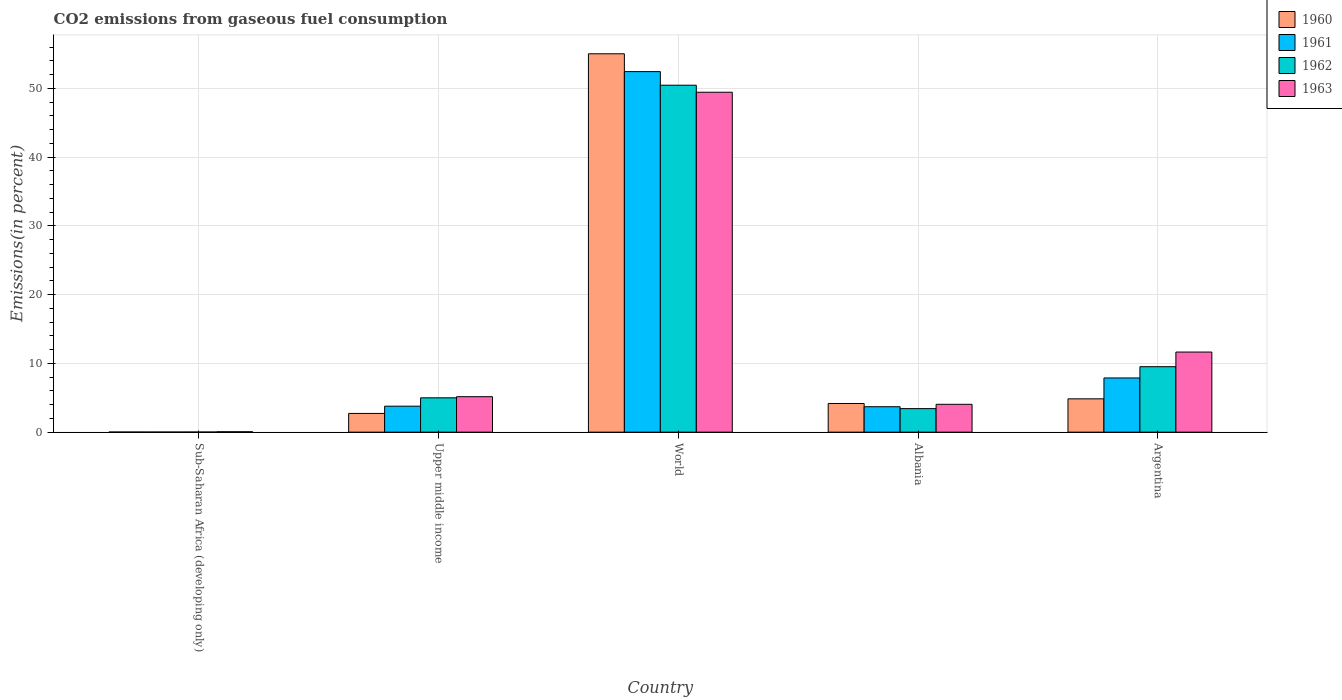How many groups of bars are there?
Ensure brevity in your answer.  5. What is the label of the 2nd group of bars from the left?
Provide a short and direct response. Upper middle income. In how many cases, is the number of bars for a given country not equal to the number of legend labels?
Make the answer very short. 0. What is the total CO2 emitted in 1960 in Argentina?
Your response must be concise. 4.85. Across all countries, what is the maximum total CO2 emitted in 1962?
Make the answer very short. 50.46. Across all countries, what is the minimum total CO2 emitted in 1962?
Give a very brief answer. 0.01. In which country was the total CO2 emitted in 1960 maximum?
Your answer should be compact. World. In which country was the total CO2 emitted in 1963 minimum?
Offer a very short reply. Sub-Saharan Africa (developing only). What is the total total CO2 emitted in 1963 in the graph?
Provide a succinct answer. 70.34. What is the difference between the total CO2 emitted in 1961 in Albania and that in Sub-Saharan Africa (developing only)?
Provide a succinct answer. 3.69. What is the difference between the total CO2 emitted in 1962 in World and the total CO2 emitted in 1960 in Sub-Saharan Africa (developing only)?
Provide a short and direct response. 50.44. What is the average total CO2 emitted in 1960 per country?
Make the answer very short. 13.35. What is the difference between the total CO2 emitted of/in 1960 and total CO2 emitted of/in 1962 in Argentina?
Your response must be concise. -4.67. In how many countries, is the total CO2 emitted in 1960 greater than 26 %?
Offer a terse response. 1. What is the ratio of the total CO2 emitted in 1962 in Sub-Saharan Africa (developing only) to that in Upper middle income?
Your answer should be very brief. 0. What is the difference between the highest and the second highest total CO2 emitted in 1963?
Offer a very short reply. 37.78. What is the difference between the highest and the lowest total CO2 emitted in 1962?
Offer a very short reply. 50.44. Is it the case that in every country, the sum of the total CO2 emitted in 1963 and total CO2 emitted in 1960 is greater than the sum of total CO2 emitted in 1961 and total CO2 emitted in 1962?
Your answer should be very brief. No. What does the 4th bar from the left in World represents?
Make the answer very short. 1963. How many bars are there?
Provide a succinct answer. 20. What is the difference between two consecutive major ticks on the Y-axis?
Provide a succinct answer. 10. Does the graph contain any zero values?
Provide a short and direct response. No. Where does the legend appear in the graph?
Your answer should be very brief. Top right. How many legend labels are there?
Provide a short and direct response. 4. What is the title of the graph?
Offer a terse response. CO2 emissions from gaseous fuel consumption. What is the label or title of the Y-axis?
Keep it short and to the point. Emissions(in percent). What is the Emissions(in percent) in 1960 in Sub-Saharan Africa (developing only)?
Make the answer very short. 0.01. What is the Emissions(in percent) of 1961 in Sub-Saharan Africa (developing only)?
Offer a very short reply. 0.01. What is the Emissions(in percent) of 1962 in Sub-Saharan Africa (developing only)?
Ensure brevity in your answer.  0.01. What is the Emissions(in percent) of 1963 in Sub-Saharan Africa (developing only)?
Keep it short and to the point. 0.06. What is the Emissions(in percent) of 1960 in Upper middle income?
Provide a succinct answer. 2.72. What is the Emissions(in percent) of 1961 in Upper middle income?
Give a very brief answer. 3.78. What is the Emissions(in percent) in 1962 in Upper middle income?
Provide a succinct answer. 4.99. What is the Emissions(in percent) in 1963 in Upper middle income?
Ensure brevity in your answer.  5.15. What is the Emissions(in percent) of 1960 in World?
Make the answer very short. 55.02. What is the Emissions(in percent) of 1961 in World?
Provide a short and direct response. 52.43. What is the Emissions(in percent) in 1962 in World?
Make the answer very short. 50.46. What is the Emissions(in percent) in 1963 in World?
Provide a short and direct response. 49.43. What is the Emissions(in percent) of 1960 in Albania?
Offer a terse response. 4.17. What is the Emissions(in percent) of 1961 in Albania?
Offer a terse response. 3.7. What is the Emissions(in percent) of 1962 in Albania?
Your response must be concise. 3.42. What is the Emissions(in percent) of 1963 in Albania?
Offer a very short reply. 4.05. What is the Emissions(in percent) of 1960 in Argentina?
Provide a succinct answer. 4.85. What is the Emissions(in percent) of 1961 in Argentina?
Give a very brief answer. 7.88. What is the Emissions(in percent) in 1962 in Argentina?
Your response must be concise. 9.52. What is the Emissions(in percent) of 1963 in Argentina?
Your answer should be very brief. 11.65. Across all countries, what is the maximum Emissions(in percent) of 1960?
Provide a short and direct response. 55.02. Across all countries, what is the maximum Emissions(in percent) of 1961?
Your answer should be very brief. 52.43. Across all countries, what is the maximum Emissions(in percent) of 1962?
Your response must be concise. 50.46. Across all countries, what is the maximum Emissions(in percent) in 1963?
Your answer should be compact. 49.43. Across all countries, what is the minimum Emissions(in percent) of 1960?
Give a very brief answer. 0.01. Across all countries, what is the minimum Emissions(in percent) of 1961?
Ensure brevity in your answer.  0.01. Across all countries, what is the minimum Emissions(in percent) of 1962?
Make the answer very short. 0.01. Across all countries, what is the minimum Emissions(in percent) in 1963?
Offer a very short reply. 0.06. What is the total Emissions(in percent) of 1960 in the graph?
Your answer should be compact. 66.77. What is the total Emissions(in percent) in 1961 in the graph?
Provide a short and direct response. 67.8. What is the total Emissions(in percent) in 1962 in the graph?
Your response must be concise. 68.41. What is the total Emissions(in percent) in 1963 in the graph?
Ensure brevity in your answer.  70.34. What is the difference between the Emissions(in percent) in 1960 in Sub-Saharan Africa (developing only) and that in Upper middle income?
Keep it short and to the point. -2.71. What is the difference between the Emissions(in percent) of 1961 in Sub-Saharan Africa (developing only) and that in Upper middle income?
Offer a very short reply. -3.77. What is the difference between the Emissions(in percent) of 1962 in Sub-Saharan Africa (developing only) and that in Upper middle income?
Keep it short and to the point. -4.98. What is the difference between the Emissions(in percent) of 1963 in Sub-Saharan Africa (developing only) and that in Upper middle income?
Your answer should be very brief. -5.1. What is the difference between the Emissions(in percent) in 1960 in Sub-Saharan Africa (developing only) and that in World?
Ensure brevity in your answer.  -55.01. What is the difference between the Emissions(in percent) in 1961 in Sub-Saharan Africa (developing only) and that in World?
Offer a very short reply. -52.42. What is the difference between the Emissions(in percent) in 1962 in Sub-Saharan Africa (developing only) and that in World?
Offer a terse response. -50.44. What is the difference between the Emissions(in percent) in 1963 in Sub-Saharan Africa (developing only) and that in World?
Ensure brevity in your answer.  -49.38. What is the difference between the Emissions(in percent) in 1960 in Sub-Saharan Africa (developing only) and that in Albania?
Your answer should be very brief. -4.15. What is the difference between the Emissions(in percent) of 1961 in Sub-Saharan Africa (developing only) and that in Albania?
Make the answer very short. -3.69. What is the difference between the Emissions(in percent) of 1962 in Sub-Saharan Africa (developing only) and that in Albania?
Your answer should be very brief. -3.41. What is the difference between the Emissions(in percent) of 1963 in Sub-Saharan Africa (developing only) and that in Albania?
Offer a very short reply. -3.99. What is the difference between the Emissions(in percent) of 1960 in Sub-Saharan Africa (developing only) and that in Argentina?
Your answer should be very brief. -4.83. What is the difference between the Emissions(in percent) of 1961 in Sub-Saharan Africa (developing only) and that in Argentina?
Your answer should be very brief. -7.87. What is the difference between the Emissions(in percent) in 1962 in Sub-Saharan Africa (developing only) and that in Argentina?
Give a very brief answer. -9.51. What is the difference between the Emissions(in percent) in 1963 in Sub-Saharan Africa (developing only) and that in Argentina?
Provide a succinct answer. -11.59. What is the difference between the Emissions(in percent) in 1960 in Upper middle income and that in World?
Provide a succinct answer. -52.3. What is the difference between the Emissions(in percent) in 1961 in Upper middle income and that in World?
Provide a succinct answer. -48.66. What is the difference between the Emissions(in percent) in 1962 in Upper middle income and that in World?
Your answer should be very brief. -45.46. What is the difference between the Emissions(in percent) in 1963 in Upper middle income and that in World?
Your answer should be very brief. -44.28. What is the difference between the Emissions(in percent) in 1960 in Upper middle income and that in Albania?
Your answer should be compact. -1.44. What is the difference between the Emissions(in percent) in 1961 in Upper middle income and that in Albania?
Give a very brief answer. 0.08. What is the difference between the Emissions(in percent) of 1962 in Upper middle income and that in Albania?
Offer a terse response. 1.57. What is the difference between the Emissions(in percent) of 1963 in Upper middle income and that in Albania?
Keep it short and to the point. 1.11. What is the difference between the Emissions(in percent) in 1960 in Upper middle income and that in Argentina?
Give a very brief answer. -2.12. What is the difference between the Emissions(in percent) in 1961 in Upper middle income and that in Argentina?
Your response must be concise. -4.1. What is the difference between the Emissions(in percent) of 1962 in Upper middle income and that in Argentina?
Offer a terse response. -4.53. What is the difference between the Emissions(in percent) of 1963 in Upper middle income and that in Argentina?
Your response must be concise. -6.49. What is the difference between the Emissions(in percent) of 1960 in World and that in Albania?
Your answer should be very brief. 50.86. What is the difference between the Emissions(in percent) in 1961 in World and that in Albania?
Offer a very short reply. 48.74. What is the difference between the Emissions(in percent) of 1962 in World and that in Albania?
Give a very brief answer. 47.03. What is the difference between the Emissions(in percent) of 1963 in World and that in Albania?
Offer a terse response. 45.38. What is the difference between the Emissions(in percent) of 1960 in World and that in Argentina?
Provide a succinct answer. 50.18. What is the difference between the Emissions(in percent) in 1961 in World and that in Argentina?
Provide a short and direct response. 44.55. What is the difference between the Emissions(in percent) of 1962 in World and that in Argentina?
Make the answer very short. 40.94. What is the difference between the Emissions(in percent) in 1963 in World and that in Argentina?
Offer a terse response. 37.78. What is the difference between the Emissions(in percent) of 1960 in Albania and that in Argentina?
Provide a short and direct response. -0.68. What is the difference between the Emissions(in percent) of 1961 in Albania and that in Argentina?
Provide a short and direct response. -4.18. What is the difference between the Emissions(in percent) of 1962 in Albania and that in Argentina?
Ensure brevity in your answer.  -6.1. What is the difference between the Emissions(in percent) in 1963 in Albania and that in Argentina?
Provide a succinct answer. -7.6. What is the difference between the Emissions(in percent) of 1960 in Sub-Saharan Africa (developing only) and the Emissions(in percent) of 1961 in Upper middle income?
Your response must be concise. -3.77. What is the difference between the Emissions(in percent) of 1960 in Sub-Saharan Africa (developing only) and the Emissions(in percent) of 1962 in Upper middle income?
Offer a very short reply. -4.98. What is the difference between the Emissions(in percent) of 1960 in Sub-Saharan Africa (developing only) and the Emissions(in percent) of 1963 in Upper middle income?
Your answer should be very brief. -5.14. What is the difference between the Emissions(in percent) of 1961 in Sub-Saharan Africa (developing only) and the Emissions(in percent) of 1962 in Upper middle income?
Offer a terse response. -4.98. What is the difference between the Emissions(in percent) in 1961 in Sub-Saharan Africa (developing only) and the Emissions(in percent) in 1963 in Upper middle income?
Offer a very short reply. -5.14. What is the difference between the Emissions(in percent) of 1962 in Sub-Saharan Africa (developing only) and the Emissions(in percent) of 1963 in Upper middle income?
Provide a short and direct response. -5.14. What is the difference between the Emissions(in percent) in 1960 in Sub-Saharan Africa (developing only) and the Emissions(in percent) in 1961 in World?
Give a very brief answer. -52.42. What is the difference between the Emissions(in percent) in 1960 in Sub-Saharan Africa (developing only) and the Emissions(in percent) in 1962 in World?
Your answer should be compact. -50.44. What is the difference between the Emissions(in percent) in 1960 in Sub-Saharan Africa (developing only) and the Emissions(in percent) in 1963 in World?
Give a very brief answer. -49.42. What is the difference between the Emissions(in percent) in 1961 in Sub-Saharan Africa (developing only) and the Emissions(in percent) in 1962 in World?
Your response must be concise. -50.44. What is the difference between the Emissions(in percent) in 1961 in Sub-Saharan Africa (developing only) and the Emissions(in percent) in 1963 in World?
Provide a succinct answer. -49.42. What is the difference between the Emissions(in percent) in 1962 in Sub-Saharan Africa (developing only) and the Emissions(in percent) in 1963 in World?
Your response must be concise. -49.42. What is the difference between the Emissions(in percent) of 1960 in Sub-Saharan Africa (developing only) and the Emissions(in percent) of 1961 in Albania?
Make the answer very short. -3.69. What is the difference between the Emissions(in percent) in 1960 in Sub-Saharan Africa (developing only) and the Emissions(in percent) in 1962 in Albania?
Your answer should be very brief. -3.41. What is the difference between the Emissions(in percent) in 1960 in Sub-Saharan Africa (developing only) and the Emissions(in percent) in 1963 in Albania?
Provide a short and direct response. -4.04. What is the difference between the Emissions(in percent) in 1961 in Sub-Saharan Africa (developing only) and the Emissions(in percent) in 1962 in Albania?
Your answer should be compact. -3.41. What is the difference between the Emissions(in percent) in 1961 in Sub-Saharan Africa (developing only) and the Emissions(in percent) in 1963 in Albania?
Offer a very short reply. -4.04. What is the difference between the Emissions(in percent) of 1962 in Sub-Saharan Africa (developing only) and the Emissions(in percent) of 1963 in Albania?
Offer a terse response. -4.03. What is the difference between the Emissions(in percent) in 1960 in Sub-Saharan Africa (developing only) and the Emissions(in percent) in 1961 in Argentina?
Offer a terse response. -7.87. What is the difference between the Emissions(in percent) of 1960 in Sub-Saharan Africa (developing only) and the Emissions(in percent) of 1962 in Argentina?
Your answer should be very brief. -9.51. What is the difference between the Emissions(in percent) of 1960 in Sub-Saharan Africa (developing only) and the Emissions(in percent) of 1963 in Argentina?
Keep it short and to the point. -11.64. What is the difference between the Emissions(in percent) in 1961 in Sub-Saharan Africa (developing only) and the Emissions(in percent) in 1962 in Argentina?
Keep it short and to the point. -9.51. What is the difference between the Emissions(in percent) in 1961 in Sub-Saharan Africa (developing only) and the Emissions(in percent) in 1963 in Argentina?
Make the answer very short. -11.64. What is the difference between the Emissions(in percent) in 1962 in Sub-Saharan Africa (developing only) and the Emissions(in percent) in 1963 in Argentina?
Keep it short and to the point. -11.63. What is the difference between the Emissions(in percent) in 1960 in Upper middle income and the Emissions(in percent) in 1961 in World?
Your response must be concise. -49.71. What is the difference between the Emissions(in percent) of 1960 in Upper middle income and the Emissions(in percent) of 1962 in World?
Provide a short and direct response. -47.73. What is the difference between the Emissions(in percent) of 1960 in Upper middle income and the Emissions(in percent) of 1963 in World?
Keep it short and to the point. -46.71. What is the difference between the Emissions(in percent) in 1961 in Upper middle income and the Emissions(in percent) in 1962 in World?
Provide a succinct answer. -46.68. What is the difference between the Emissions(in percent) in 1961 in Upper middle income and the Emissions(in percent) in 1963 in World?
Your answer should be compact. -45.66. What is the difference between the Emissions(in percent) of 1962 in Upper middle income and the Emissions(in percent) of 1963 in World?
Ensure brevity in your answer.  -44.44. What is the difference between the Emissions(in percent) in 1960 in Upper middle income and the Emissions(in percent) in 1961 in Albania?
Ensure brevity in your answer.  -0.98. What is the difference between the Emissions(in percent) in 1960 in Upper middle income and the Emissions(in percent) in 1962 in Albania?
Provide a short and direct response. -0.7. What is the difference between the Emissions(in percent) in 1960 in Upper middle income and the Emissions(in percent) in 1963 in Albania?
Give a very brief answer. -1.33. What is the difference between the Emissions(in percent) in 1961 in Upper middle income and the Emissions(in percent) in 1962 in Albania?
Your answer should be compact. 0.35. What is the difference between the Emissions(in percent) of 1961 in Upper middle income and the Emissions(in percent) of 1963 in Albania?
Provide a short and direct response. -0.27. What is the difference between the Emissions(in percent) of 1962 in Upper middle income and the Emissions(in percent) of 1963 in Albania?
Ensure brevity in your answer.  0.94. What is the difference between the Emissions(in percent) of 1960 in Upper middle income and the Emissions(in percent) of 1961 in Argentina?
Give a very brief answer. -5.16. What is the difference between the Emissions(in percent) of 1960 in Upper middle income and the Emissions(in percent) of 1962 in Argentina?
Your answer should be very brief. -6.8. What is the difference between the Emissions(in percent) in 1960 in Upper middle income and the Emissions(in percent) in 1963 in Argentina?
Your answer should be compact. -8.93. What is the difference between the Emissions(in percent) in 1961 in Upper middle income and the Emissions(in percent) in 1962 in Argentina?
Provide a short and direct response. -5.74. What is the difference between the Emissions(in percent) of 1961 in Upper middle income and the Emissions(in percent) of 1963 in Argentina?
Provide a short and direct response. -7.87. What is the difference between the Emissions(in percent) of 1962 in Upper middle income and the Emissions(in percent) of 1963 in Argentina?
Your answer should be very brief. -6.66. What is the difference between the Emissions(in percent) in 1960 in World and the Emissions(in percent) in 1961 in Albania?
Give a very brief answer. 51.33. What is the difference between the Emissions(in percent) of 1960 in World and the Emissions(in percent) of 1962 in Albania?
Ensure brevity in your answer.  51.6. What is the difference between the Emissions(in percent) of 1960 in World and the Emissions(in percent) of 1963 in Albania?
Make the answer very short. 50.98. What is the difference between the Emissions(in percent) in 1961 in World and the Emissions(in percent) in 1962 in Albania?
Provide a succinct answer. 49.01. What is the difference between the Emissions(in percent) in 1961 in World and the Emissions(in percent) in 1963 in Albania?
Make the answer very short. 48.38. What is the difference between the Emissions(in percent) in 1962 in World and the Emissions(in percent) in 1963 in Albania?
Provide a succinct answer. 46.41. What is the difference between the Emissions(in percent) in 1960 in World and the Emissions(in percent) in 1961 in Argentina?
Provide a short and direct response. 47.14. What is the difference between the Emissions(in percent) in 1960 in World and the Emissions(in percent) in 1962 in Argentina?
Your answer should be compact. 45.5. What is the difference between the Emissions(in percent) in 1960 in World and the Emissions(in percent) in 1963 in Argentina?
Offer a terse response. 43.38. What is the difference between the Emissions(in percent) of 1961 in World and the Emissions(in percent) of 1962 in Argentina?
Give a very brief answer. 42.91. What is the difference between the Emissions(in percent) of 1961 in World and the Emissions(in percent) of 1963 in Argentina?
Your response must be concise. 40.78. What is the difference between the Emissions(in percent) of 1962 in World and the Emissions(in percent) of 1963 in Argentina?
Keep it short and to the point. 38.81. What is the difference between the Emissions(in percent) of 1960 in Albania and the Emissions(in percent) of 1961 in Argentina?
Offer a very short reply. -3.71. What is the difference between the Emissions(in percent) in 1960 in Albania and the Emissions(in percent) in 1962 in Argentina?
Your answer should be very brief. -5.35. What is the difference between the Emissions(in percent) in 1960 in Albania and the Emissions(in percent) in 1963 in Argentina?
Offer a very short reply. -7.48. What is the difference between the Emissions(in percent) in 1961 in Albania and the Emissions(in percent) in 1962 in Argentina?
Keep it short and to the point. -5.82. What is the difference between the Emissions(in percent) in 1961 in Albania and the Emissions(in percent) in 1963 in Argentina?
Give a very brief answer. -7.95. What is the difference between the Emissions(in percent) of 1962 in Albania and the Emissions(in percent) of 1963 in Argentina?
Your response must be concise. -8.23. What is the average Emissions(in percent) in 1960 per country?
Provide a succinct answer. 13.35. What is the average Emissions(in percent) in 1961 per country?
Provide a short and direct response. 13.56. What is the average Emissions(in percent) in 1962 per country?
Ensure brevity in your answer.  13.68. What is the average Emissions(in percent) in 1963 per country?
Your answer should be very brief. 14.07. What is the difference between the Emissions(in percent) of 1960 and Emissions(in percent) of 1962 in Sub-Saharan Africa (developing only)?
Provide a succinct answer. -0. What is the difference between the Emissions(in percent) in 1960 and Emissions(in percent) in 1963 in Sub-Saharan Africa (developing only)?
Offer a very short reply. -0.05. What is the difference between the Emissions(in percent) of 1961 and Emissions(in percent) of 1962 in Sub-Saharan Africa (developing only)?
Ensure brevity in your answer.  -0. What is the difference between the Emissions(in percent) of 1961 and Emissions(in percent) of 1963 in Sub-Saharan Africa (developing only)?
Offer a very short reply. -0.05. What is the difference between the Emissions(in percent) in 1962 and Emissions(in percent) in 1963 in Sub-Saharan Africa (developing only)?
Keep it short and to the point. -0.04. What is the difference between the Emissions(in percent) in 1960 and Emissions(in percent) in 1961 in Upper middle income?
Your response must be concise. -1.06. What is the difference between the Emissions(in percent) in 1960 and Emissions(in percent) in 1962 in Upper middle income?
Your answer should be compact. -2.27. What is the difference between the Emissions(in percent) in 1960 and Emissions(in percent) in 1963 in Upper middle income?
Provide a short and direct response. -2.43. What is the difference between the Emissions(in percent) of 1961 and Emissions(in percent) of 1962 in Upper middle income?
Offer a terse response. -1.22. What is the difference between the Emissions(in percent) of 1961 and Emissions(in percent) of 1963 in Upper middle income?
Provide a succinct answer. -1.38. What is the difference between the Emissions(in percent) of 1962 and Emissions(in percent) of 1963 in Upper middle income?
Provide a short and direct response. -0.16. What is the difference between the Emissions(in percent) of 1960 and Emissions(in percent) of 1961 in World?
Your answer should be compact. 2.59. What is the difference between the Emissions(in percent) of 1960 and Emissions(in percent) of 1962 in World?
Offer a terse response. 4.57. What is the difference between the Emissions(in percent) of 1960 and Emissions(in percent) of 1963 in World?
Keep it short and to the point. 5.59. What is the difference between the Emissions(in percent) in 1961 and Emissions(in percent) in 1962 in World?
Ensure brevity in your answer.  1.98. What is the difference between the Emissions(in percent) in 1961 and Emissions(in percent) in 1963 in World?
Your answer should be compact. 3. What is the difference between the Emissions(in percent) in 1962 and Emissions(in percent) in 1963 in World?
Keep it short and to the point. 1.02. What is the difference between the Emissions(in percent) in 1960 and Emissions(in percent) in 1961 in Albania?
Your answer should be compact. 0.47. What is the difference between the Emissions(in percent) in 1960 and Emissions(in percent) in 1962 in Albania?
Your response must be concise. 0.74. What is the difference between the Emissions(in percent) in 1960 and Emissions(in percent) in 1963 in Albania?
Your answer should be compact. 0.12. What is the difference between the Emissions(in percent) in 1961 and Emissions(in percent) in 1962 in Albania?
Make the answer very short. 0.28. What is the difference between the Emissions(in percent) of 1961 and Emissions(in percent) of 1963 in Albania?
Your answer should be very brief. -0.35. What is the difference between the Emissions(in percent) of 1962 and Emissions(in percent) of 1963 in Albania?
Offer a terse response. -0.63. What is the difference between the Emissions(in percent) of 1960 and Emissions(in percent) of 1961 in Argentina?
Make the answer very short. -3.04. What is the difference between the Emissions(in percent) of 1960 and Emissions(in percent) of 1962 in Argentina?
Ensure brevity in your answer.  -4.67. What is the difference between the Emissions(in percent) in 1960 and Emissions(in percent) in 1963 in Argentina?
Your answer should be compact. -6.8. What is the difference between the Emissions(in percent) in 1961 and Emissions(in percent) in 1962 in Argentina?
Your answer should be very brief. -1.64. What is the difference between the Emissions(in percent) of 1961 and Emissions(in percent) of 1963 in Argentina?
Your answer should be compact. -3.77. What is the difference between the Emissions(in percent) of 1962 and Emissions(in percent) of 1963 in Argentina?
Give a very brief answer. -2.13. What is the ratio of the Emissions(in percent) of 1960 in Sub-Saharan Africa (developing only) to that in Upper middle income?
Provide a succinct answer. 0. What is the ratio of the Emissions(in percent) of 1961 in Sub-Saharan Africa (developing only) to that in Upper middle income?
Your answer should be very brief. 0. What is the ratio of the Emissions(in percent) in 1962 in Sub-Saharan Africa (developing only) to that in Upper middle income?
Ensure brevity in your answer.  0. What is the ratio of the Emissions(in percent) in 1963 in Sub-Saharan Africa (developing only) to that in Upper middle income?
Offer a very short reply. 0.01. What is the ratio of the Emissions(in percent) in 1960 in Sub-Saharan Africa (developing only) to that in World?
Provide a succinct answer. 0. What is the ratio of the Emissions(in percent) in 1961 in Sub-Saharan Africa (developing only) to that in World?
Keep it short and to the point. 0. What is the ratio of the Emissions(in percent) in 1963 in Sub-Saharan Africa (developing only) to that in World?
Your response must be concise. 0. What is the ratio of the Emissions(in percent) of 1960 in Sub-Saharan Africa (developing only) to that in Albania?
Keep it short and to the point. 0. What is the ratio of the Emissions(in percent) in 1961 in Sub-Saharan Africa (developing only) to that in Albania?
Offer a very short reply. 0. What is the ratio of the Emissions(in percent) in 1962 in Sub-Saharan Africa (developing only) to that in Albania?
Keep it short and to the point. 0. What is the ratio of the Emissions(in percent) in 1963 in Sub-Saharan Africa (developing only) to that in Albania?
Provide a short and direct response. 0.01. What is the ratio of the Emissions(in percent) of 1960 in Sub-Saharan Africa (developing only) to that in Argentina?
Keep it short and to the point. 0. What is the ratio of the Emissions(in percent) of 1961 in Sub-Saharan Africa (developing only) to that in Argentina?
Provide a succinct answer. 0. What is the ratio of the Emissions(in percent) of 1962 in Sub-Saharan Africa (developing only) to that in Argentina?
Make the answer very short. 0. What is the ratio of the Emissions(in percent) in 1963 in Sub-Saharan Africa (developing only) to that in Argentina?
Ensure brevity in your answer.  0. What is the ratio of the Emissions(in percent) of 1960 in Upper middle income to that in World?
Ensure brevity in your answer.  0.05. What is the ratio of the Emissions(in percent) of 1961 in Upper middle income to that in World?
Provide a short and direct response. 0.07. What is the ratio of the Emissions(in percent) of 1962 in Upper middle income to that in World?
Offer a very short reply. 0.1. What is the ratio of the Emissions(in percent) of 1963 in Upper middle income to that in World?
Make the answer very short. 0.1. What is the ratio of the Emissions(in percent) of 1960 in Upper middle income to that in Albania?
Provide a succinct answer. 0.65. What is the ratio of the Emissions(in percent) in 1961 in Upper middle income to that in Albania?
Your answer should be very brief. 1.02. What is the ratio of the Emissions(in percent) in 1962 in Upper middle income to that in Albania?
Your response must be concise. 1.46. What is the ratio of the Emissions(in percent) in 1963 in Upper middle income to that in Albania?
Offer a terse response. 1.27. What is the ratio of the Emissions(in percent) of 1960 in Upper middle income to that in Argentina?
Your response must be concise. 0.56. What is the ratio of the Emissions(in percent) of 1961 in Upper middle income to that in Argentina?
Offer a very short reply. 0.48. What is the ratio of the Emissions(in percent) of 1962 in Upper middle income to that in Argentina?
Ensure brevity in your answer.  0.52. What is the ratio of the Emissions(in percent) of 1963 in Upper middle income to that in Argentina?
Offer a very short reply. 0.44. What is the ratio of the Emissions(in percent) of 1960 in World to that in Albania?
Provide a succinct answer. 13.21. What is the ratio of the Emissions(in percent) in 1961 in World to that in Albania?
Your answer should be compact. 14.18. What is the ratio of the Emissions(in percent) in 1962 in World to that in Albania?
Provide a succinct answer. 14.74. What is the ratio of the Emissions(in percent) in 1963 in World to that in Albania?
Ensure brevity in your answer.  12.21. What is the ratio of the Emissions(in percent) of 1960 in World to that in Argentina?
Keep it short and to the point. 11.36. What is the ratio of the Emissions(in percent) in 1961 in World to that in Argentina?
Provide a short and direct response. 6.65. What is the ratio of the Emissions(in percent) of 1963 in World to that in Argentina?
Give a very brief answer. 4.24. What is the ratio of the Emissions(in percent) of 1960 in Albania to that in Argentina?
Offer a terse response. 0.86. What is the ratio of the Emissions(in percent) of 1961 in Albania to that in Argentina?
Ensure brevity in your answer.  0.47. What is the ratio of the Emissions(in percent) of 1962 in Albania to that in Argentina?
Ensure brevity in your answer.  0.36. What is the ratio of the Emissions(in percent) in 1963 in Albania to that in Argentina?
Provide a succinct answer. 0.35. What is the difference between the highest and the second highest Emissions(in percent) in 1960?
Offer a very short reply. 50.18. What is the difference between the highest and the second highest Emissions(in percent) of 1961?
Ensure brevity in your answer.  44.55. What is the difference between the highest and the second highest Emissions(in percent) in 1962?
Give a very brief answer. 40.94. What is the difference between the highest and the second highest Emissions(in percent) of 1963?
Provide a short and direct response. 37.78. What is the difference between the highest and the lowest Emissions(in percent) in 1960?
Give a very brief answer. 55.01. What is the difference between the highest and the lowest Emissions(in percent) of 1961?
Ensure brevity in your answer.  52.42. What is the difference between the highest and the lowest Emissions(in percent) in 1962?
Keep it short and to the point. 50.44. What is the difference between the highest and the lowest Emissions(in percent) of 1963?
Offer a very short reply. 49.38. 